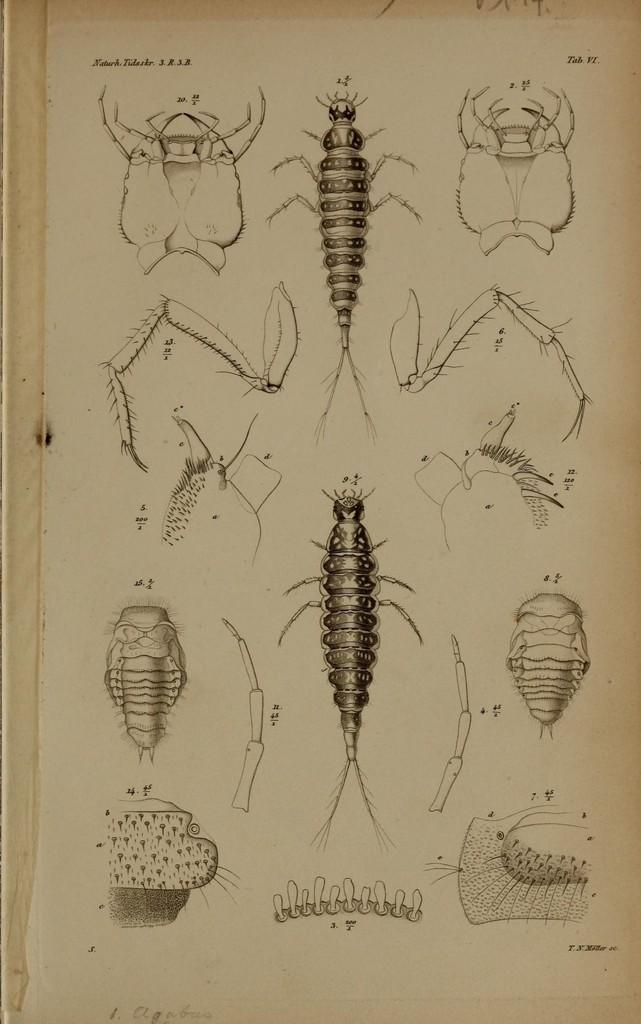What is the main subject of the image? The main subject of the image is a chart. What is depicted on the chart? The chart contains a diagram of an insect. What information does the diagram provide about the insect? The diagram shows the parts of the insect. How many seats are available for the insect in the image? There are no seats present in the image, as it features a chart with a diagram of an insect. 